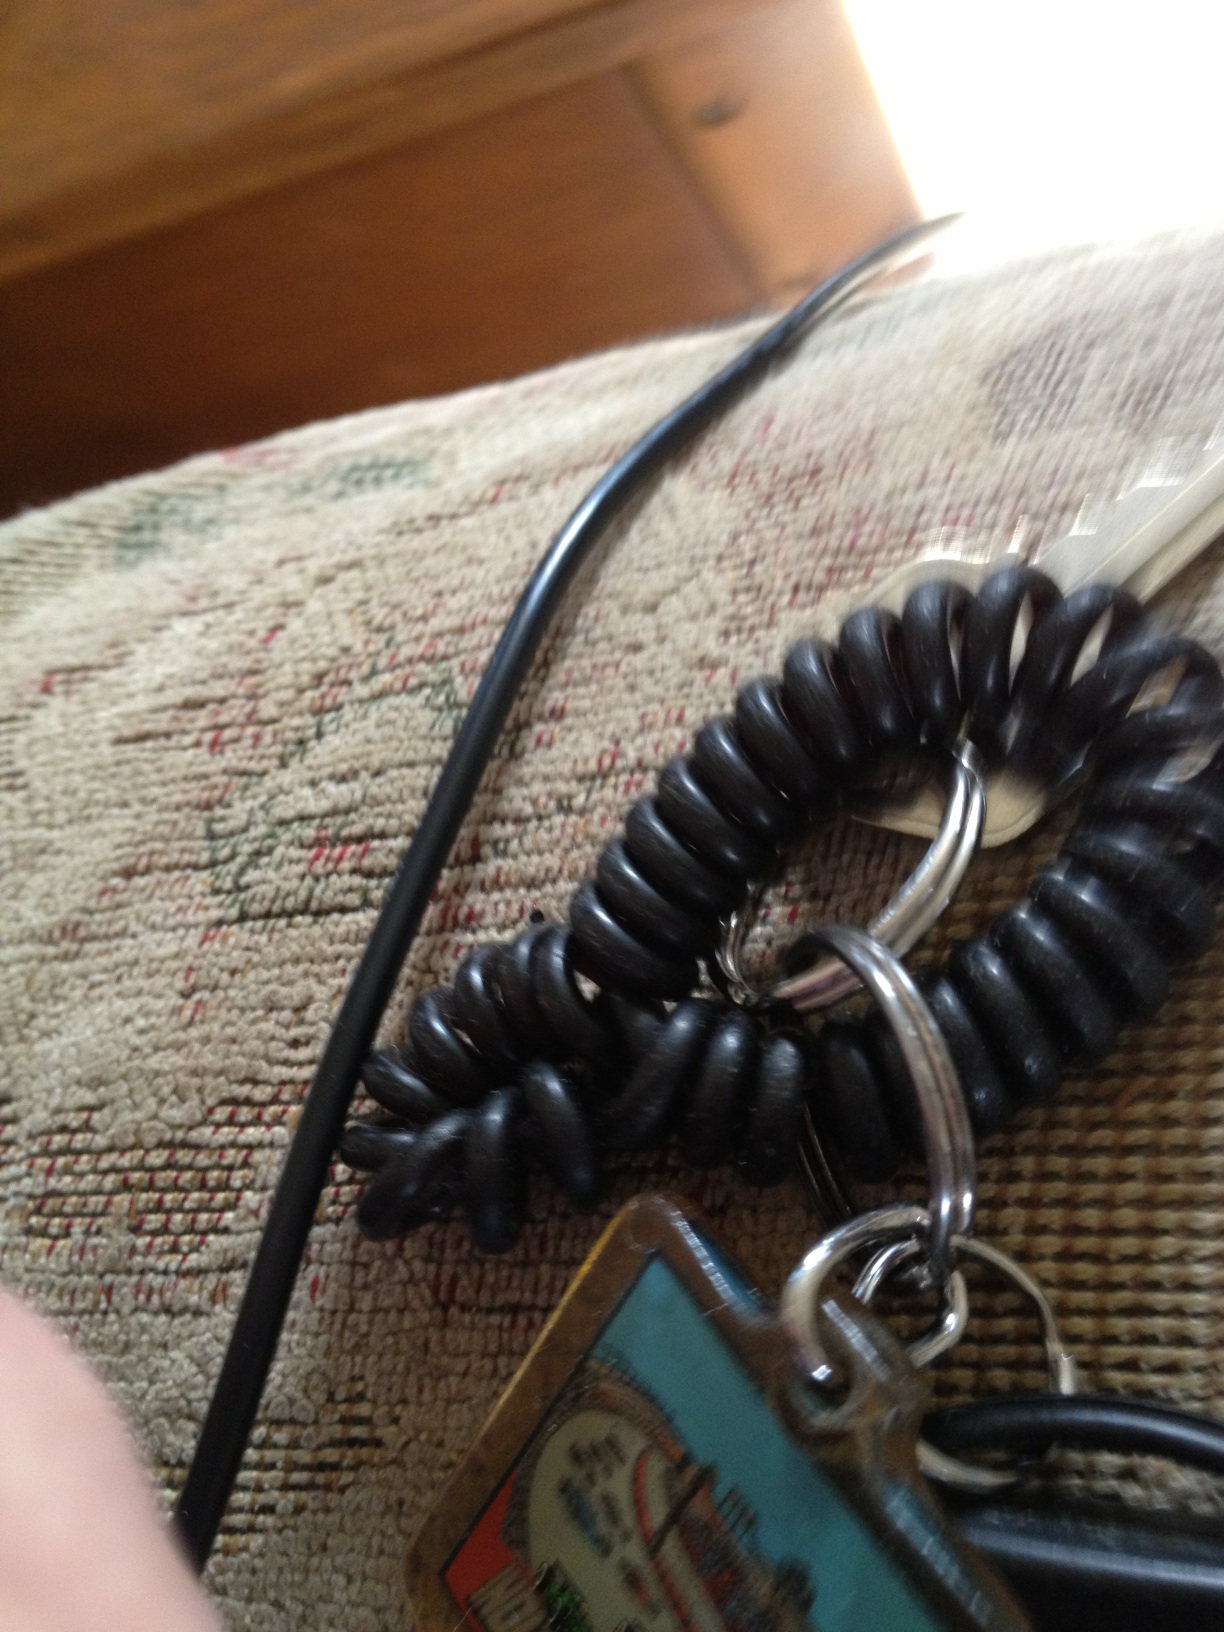Imagine if this keychain could tell a story, what would it say about its adventures? Oh, what a tale this keychain would have! 'I've traveled across cities, jingling in pockets and bags, opening doors to new adventures. I've seen sunrises over mountains and sunsets by the sea, been a part of cheers in stadiums and quiet nights by the fireplace. Each scratch on my surface tells a story of a day well-lived.' 